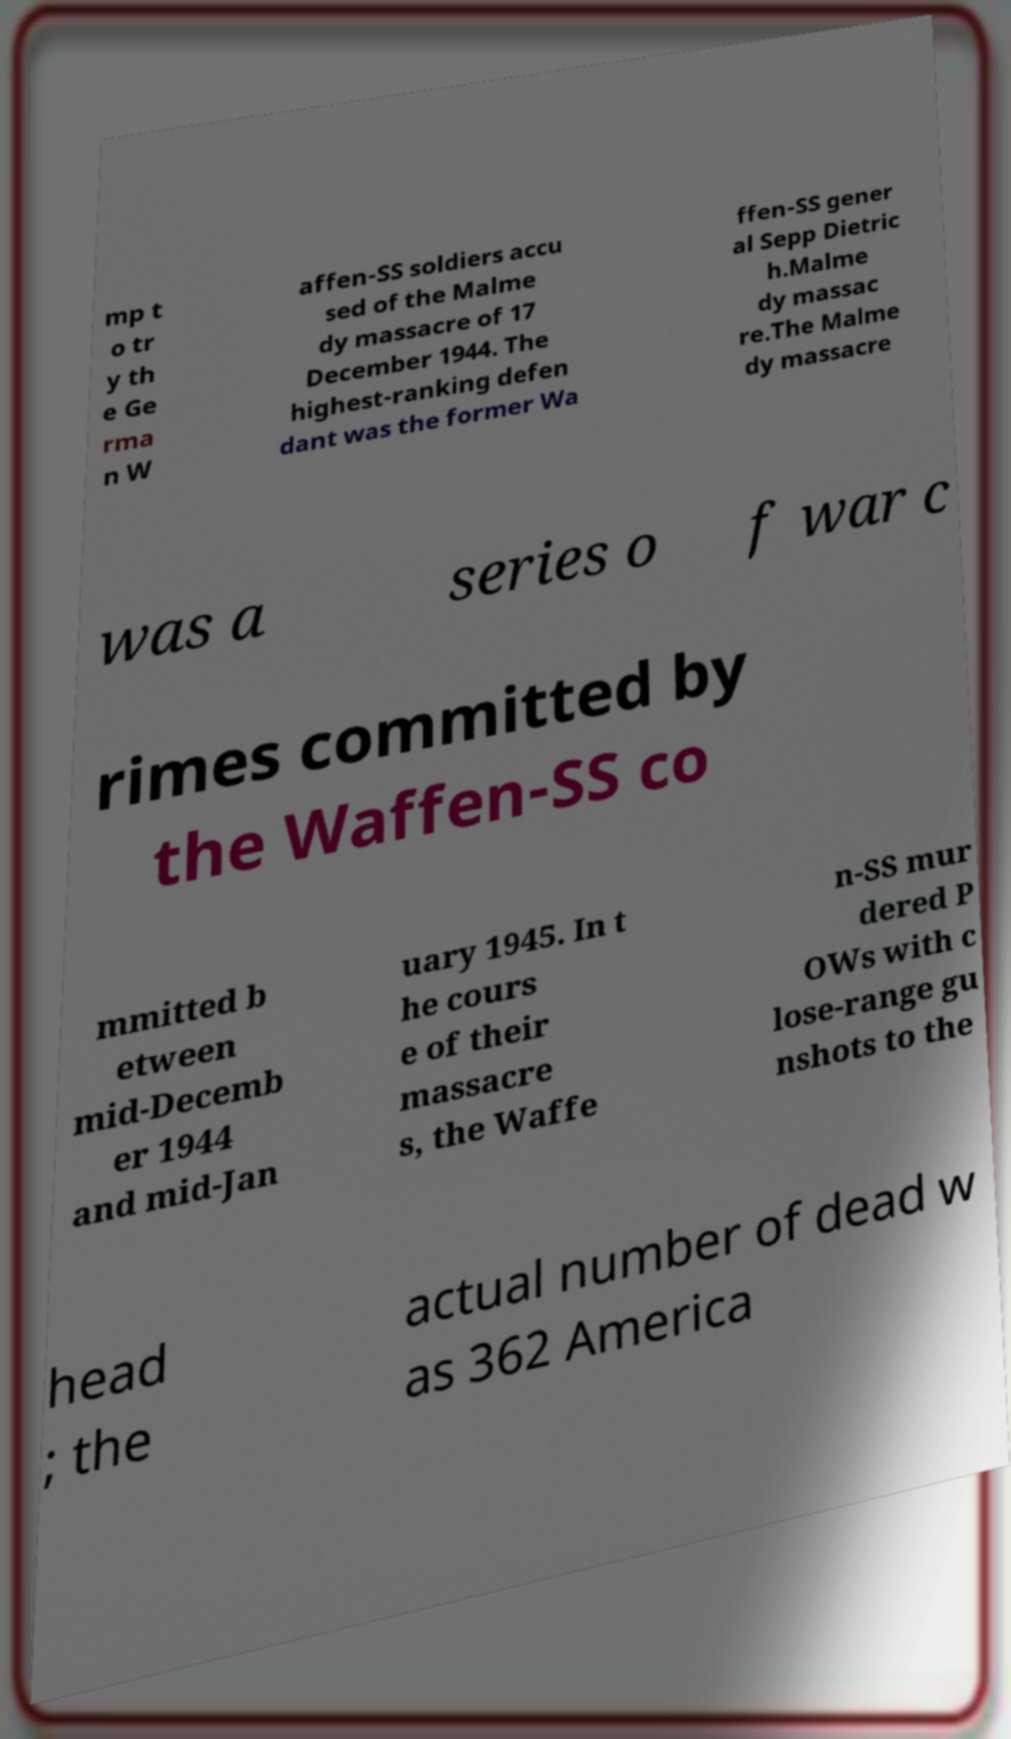What messages or text are displayed in this image? I need them in a readable, typed format. mp t o tr y th e Ge rma n W affen-SS soldiers accu sed of the Malme dy massacre of 17 December 1944. The highest-ranking defen dant was the former Wa ffen-SS gener al Sepp Dietric h.Malme dy massac re.The Malme dy massacre was a series o f war c rimes committed by the Waffen-SS co mmitted b etween mid-Decemb er 1944 and mid-Jan uary 1945. In t he cours e of their massacre s, the Waffe n-SS mur dered P OWs with c lose-range gu nshots to the head ; the actual number of dead w as 362 America 